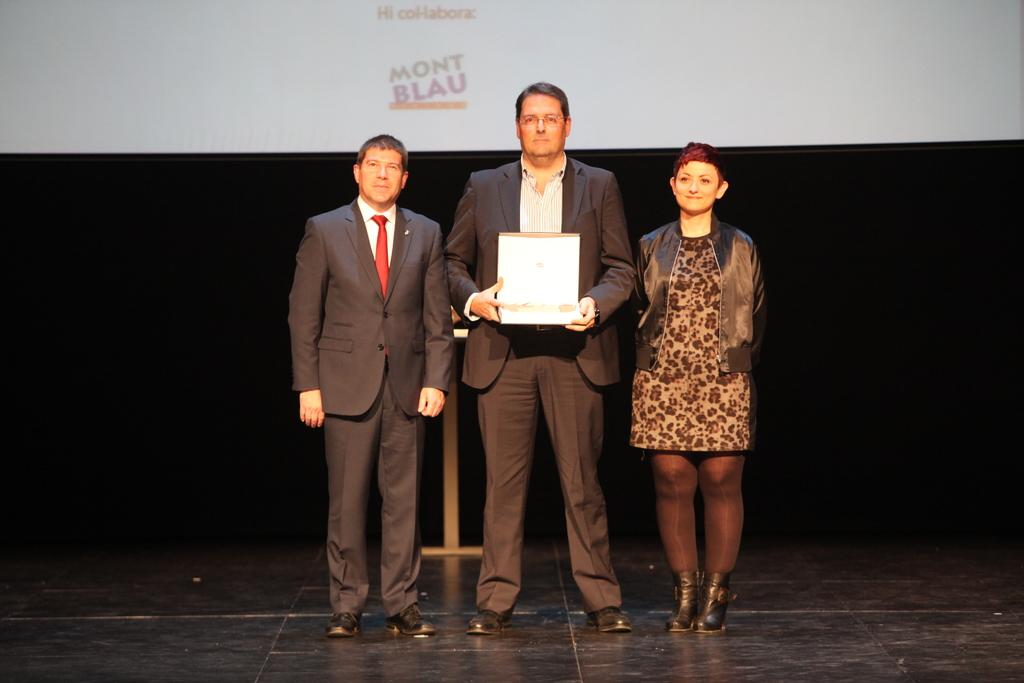How many people are in the image? There are three persons in the image. Where are the persons located in the image? The persons are on the floor. What is the center person doing in the image? The center person is holding an object. What can be seen in the background of the image? There is a display screen in the background of the image. What is the color of the display screen? The display screen is white in color. What information is visible on the display screen? There is text visible on the display screen. What type of liquid is being poured on the persons in the image? There is no liquid being poured on the persons in the image. What news headline is visible on the display screen? There is no news headline visible on the display screen, as the text is not specified in the provided facts. 